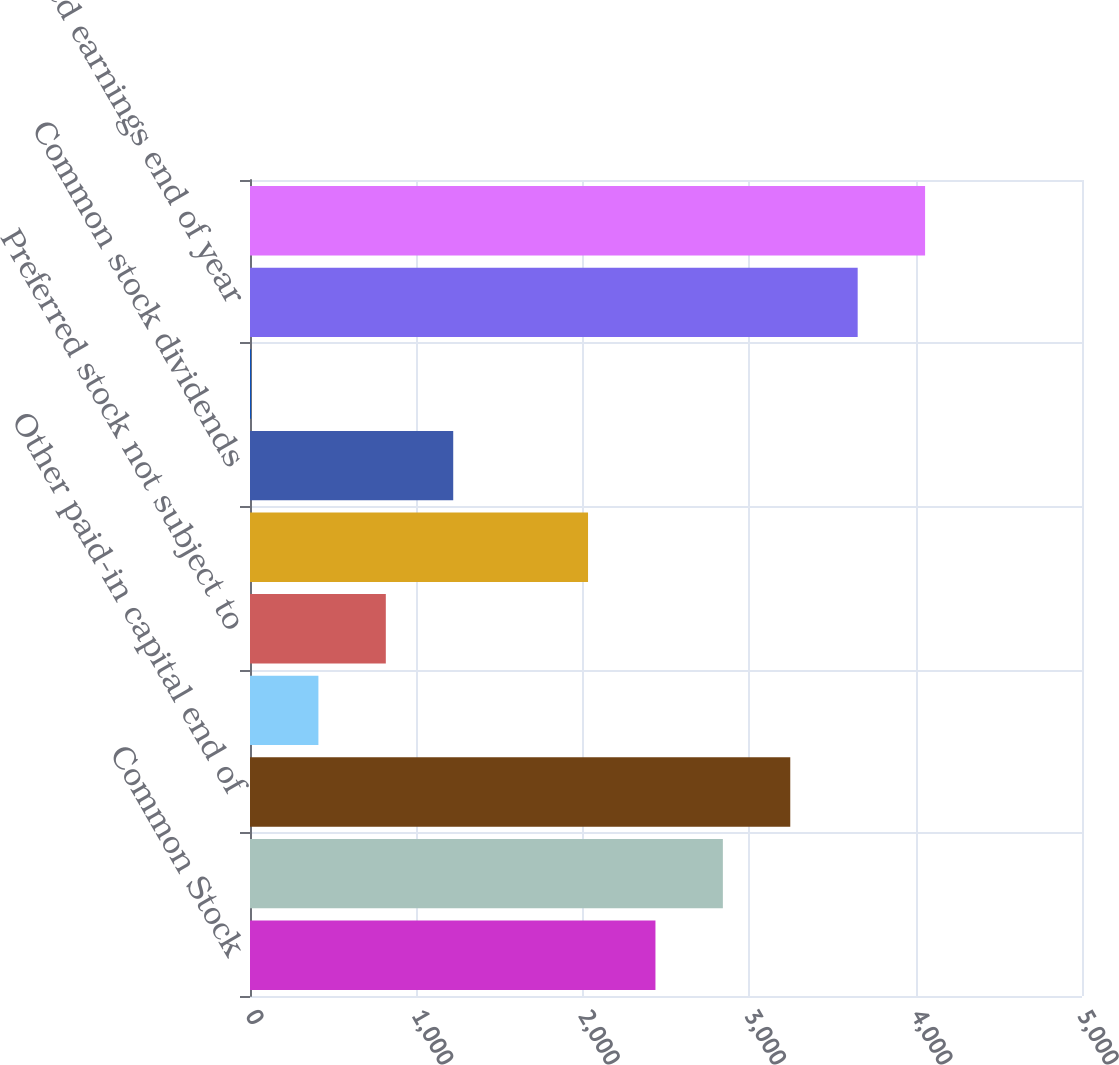Convert chart. <chart><loc_0><loc_0><loc_500><loc_500><bar_chart><fcel>Common Stock<fcel>Beginning of year<fcel>Other paid-in capital end of<fcel>Beginning balance<fcel>Preferred stock not subject to<fcel>Net income<fcel>Common stock dividends<fcel>Preferred stock dividends<fcel>Retained earnings end of year<fcel>Total Stockholders' Equity<nl><fcel>2436.6<fcel>2841.7<fcel>3246.8<fcel>411.1<fcel>816.2<fcel>2031.5<fcel>1221.3<fcel>6<fcel>3651.9<fcel>4057<nl></chart> 